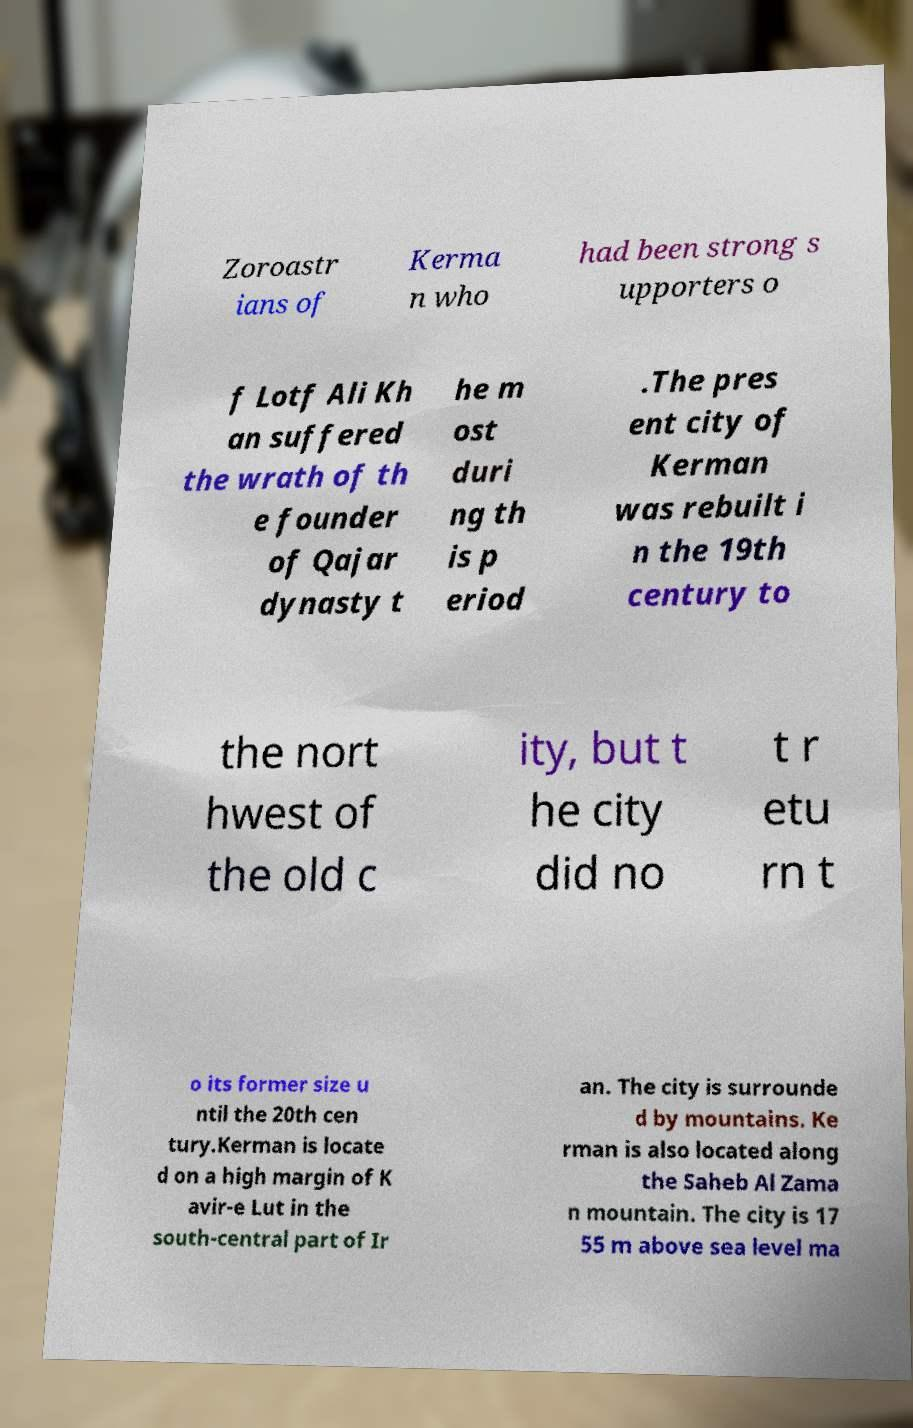Please read and relay the text visible in this image. What does it say? Zoroastr ians of Kerma n who had been strong s upporters o f Lotf Ali Kh an suffered the wrath of th e founder of Qajar dynasty t he m ost duri ng th is p eriod .The pres ent city of Kerman was rebuilt i n the 19th century to the nort hwest of the old c ity, but t he city did no t r etu rn t o its former size u ntil the 20th cen tury.Kerman is locate d on a high margin of K avir-e Lut in the south-central part of Ir an. The city is surrounde d by mountains. Ke rman is also located along the Saheb Al Zama n mountain. The city is 17 55 m above sea level ma 